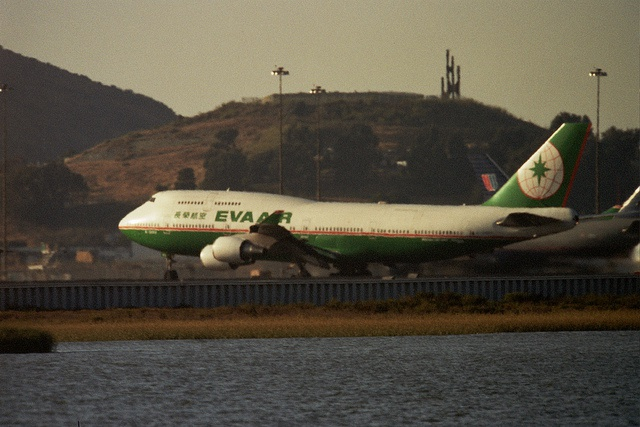Describe the objects in this image and their specific colors. I can see a airplane in darkgray, black, and tan tones in this image. 